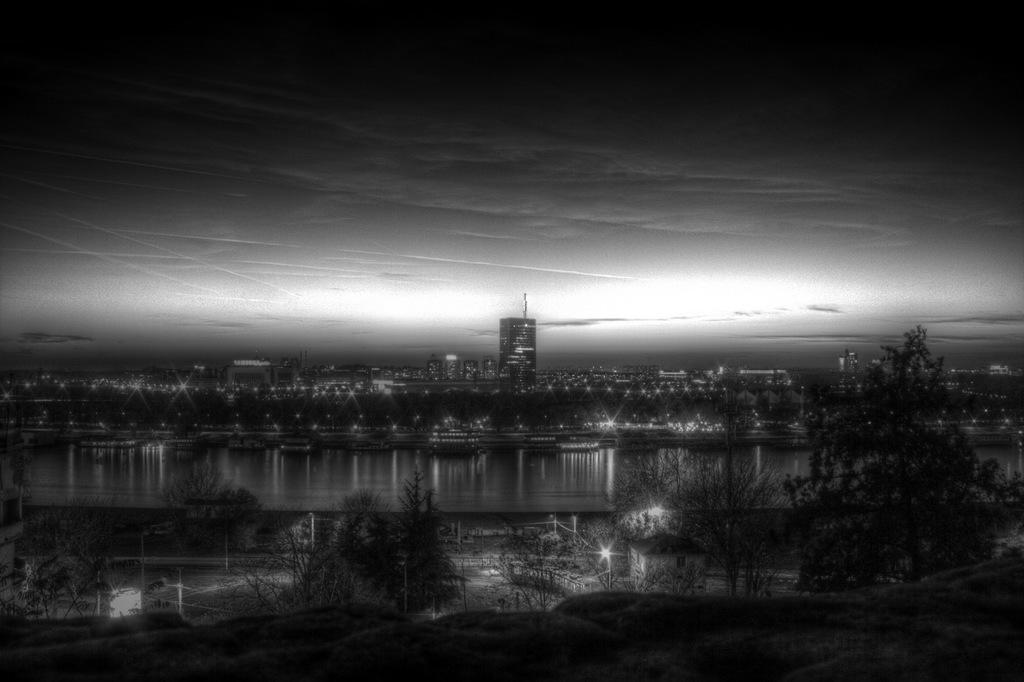What is the overall lighting condition in the image? The image is dark. What type of natural elements can be seen in the image? There are trees in the image. What type of man-made structures are present in the image? There are buildings in the image. What is the condition of the sky in the image? The sky is visible in the image. What type of artificial light sources are present in the image? There are lights in the image. What impulse causes the trees to fall in the image? There is no indication in the image that the trees are falling, and therefore no such impulse can be observed. How many men are visible in the image? There is no man present in the image; it features trees, buildings, lights, and a dark sky. 